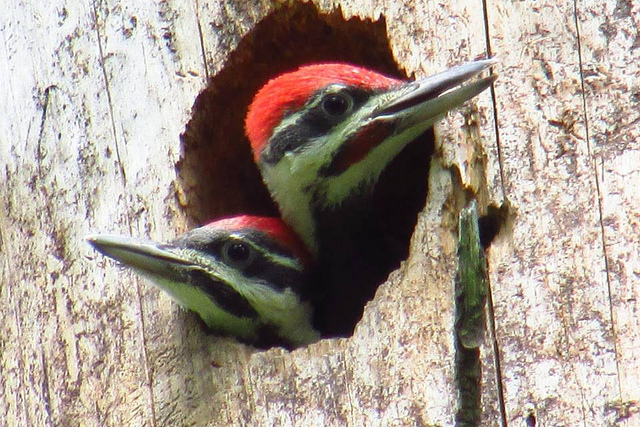Are these birds common or rare to encounter? Pileated woodpeckers are relatively common within their range but can appear elusive due to their preference for dense forest environments. Their distinct drumming on tree trunks can often reveal their presence. 